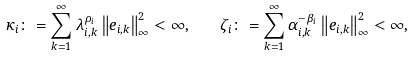Convert formula to latex. <formula><loc_0><loc_0><loc_500><loc_500>\kappa _ { i } \colon = \sum _ { k = 1 } ^ { \infty } { \lambda _ { i , k } ^ { \rho _ { i } } \left \| e _ { i , k } \right \| _ { \infty } ^ { 2 } } < \infty , \quad \zeta _ { i } \colon = \sum _ { k = 1 } ^ { \infty } { \alpha _ { i , k } ^ { - \beta _ { i } } \left \| e _ { i , k } \right \| _ { \infty } ^ { 2 } } < \infty ,</formula> 